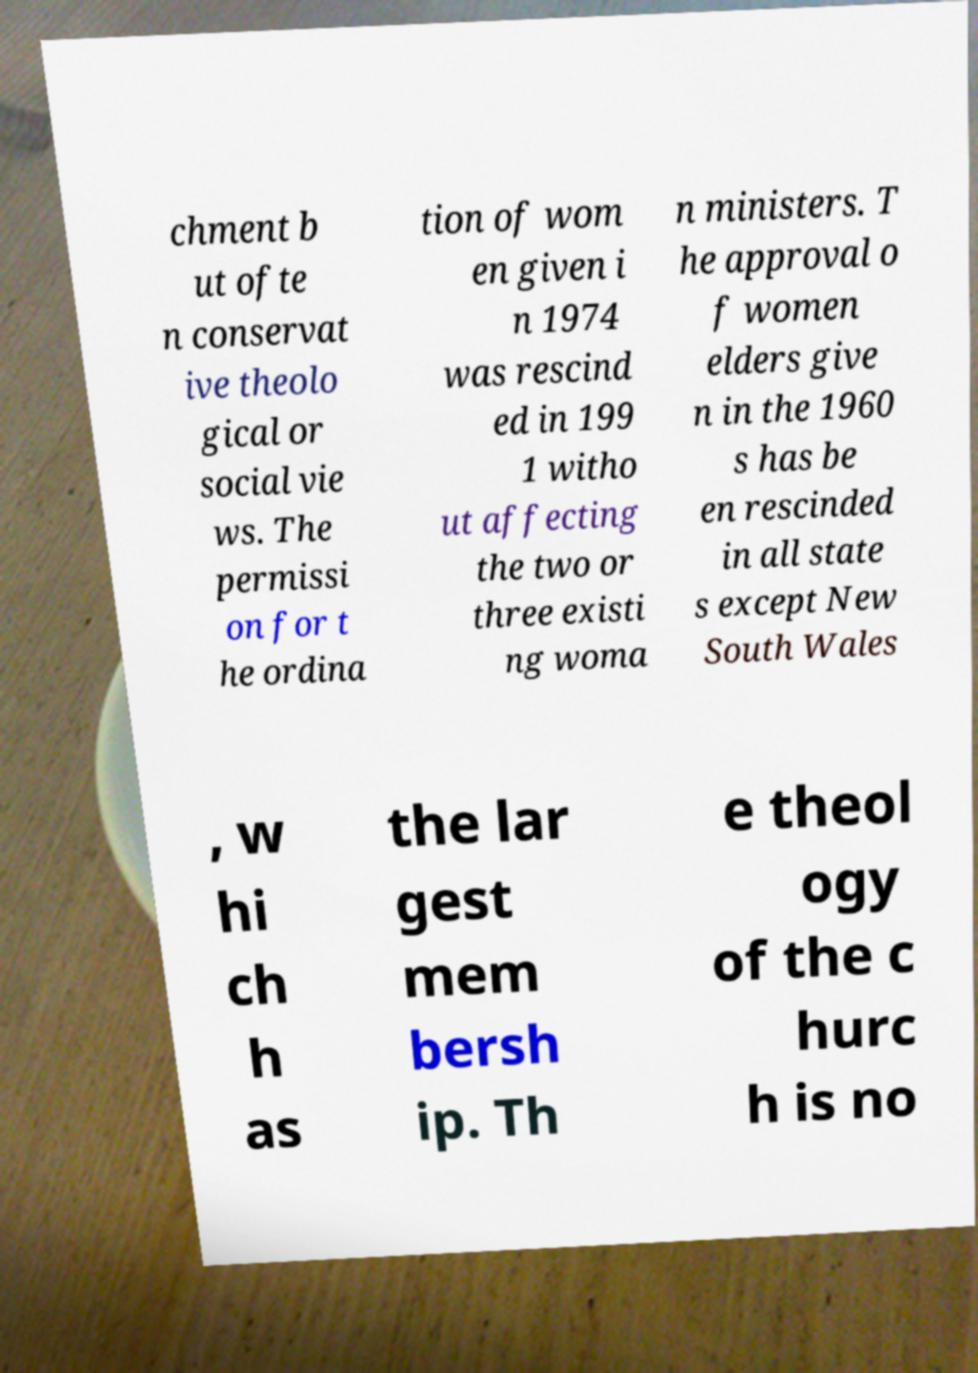Could you extract and type out the text from this image? chment b ut ofte n conservat ive theolo gical or social vie ws. The permissi on for t he ordina tion of wom en given i n 1974 was rescind ed in 199 1 witho ut affecting the two or three existi ng woma n ministers. T he approval o f women elders give n in the 1960 s has be en rescinded in all state s except New South Wales , w hi ch h as the lar gest mem bersh ip. Th e theol ogy of the c hurc h is no 